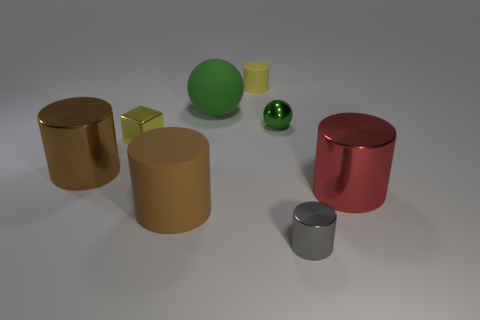Subtract all metal cylinders. How many cylinders are left? 2 Add 1 purple matte spheres. How many objects exist? 9 Subtract all yellow cylinders. How many cylinders are left? 4 Subtract all yellow spheres. How many brown cylinders are left? 2 Subtract all cubes. How many objects are left? 7 Add 4 tiny yellow metal blocks. How many tiny yellow metal blocks are left? 5 Add 5 yellow metallic cylinders. How many yellow metallic cylinders exist? 5 Subtract 0 red blocks. How many objects are left? 8 Subtract 2 spheres. How many spheres are left? 0 Subtract all blue balls. Subtract all purple cylinders. How many balls are left? 2 